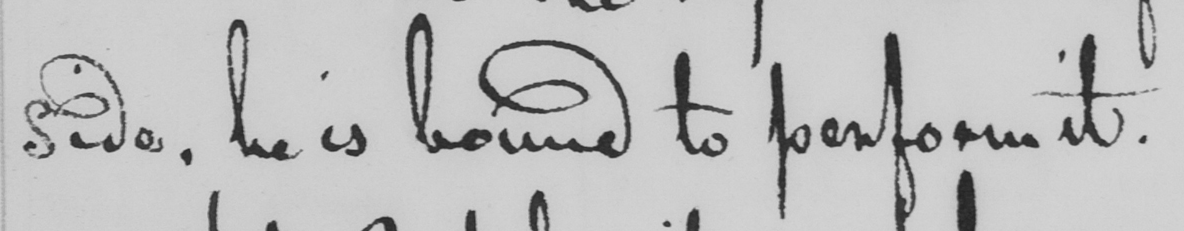What does this handwritten line say? side , he is bound to perform it . 